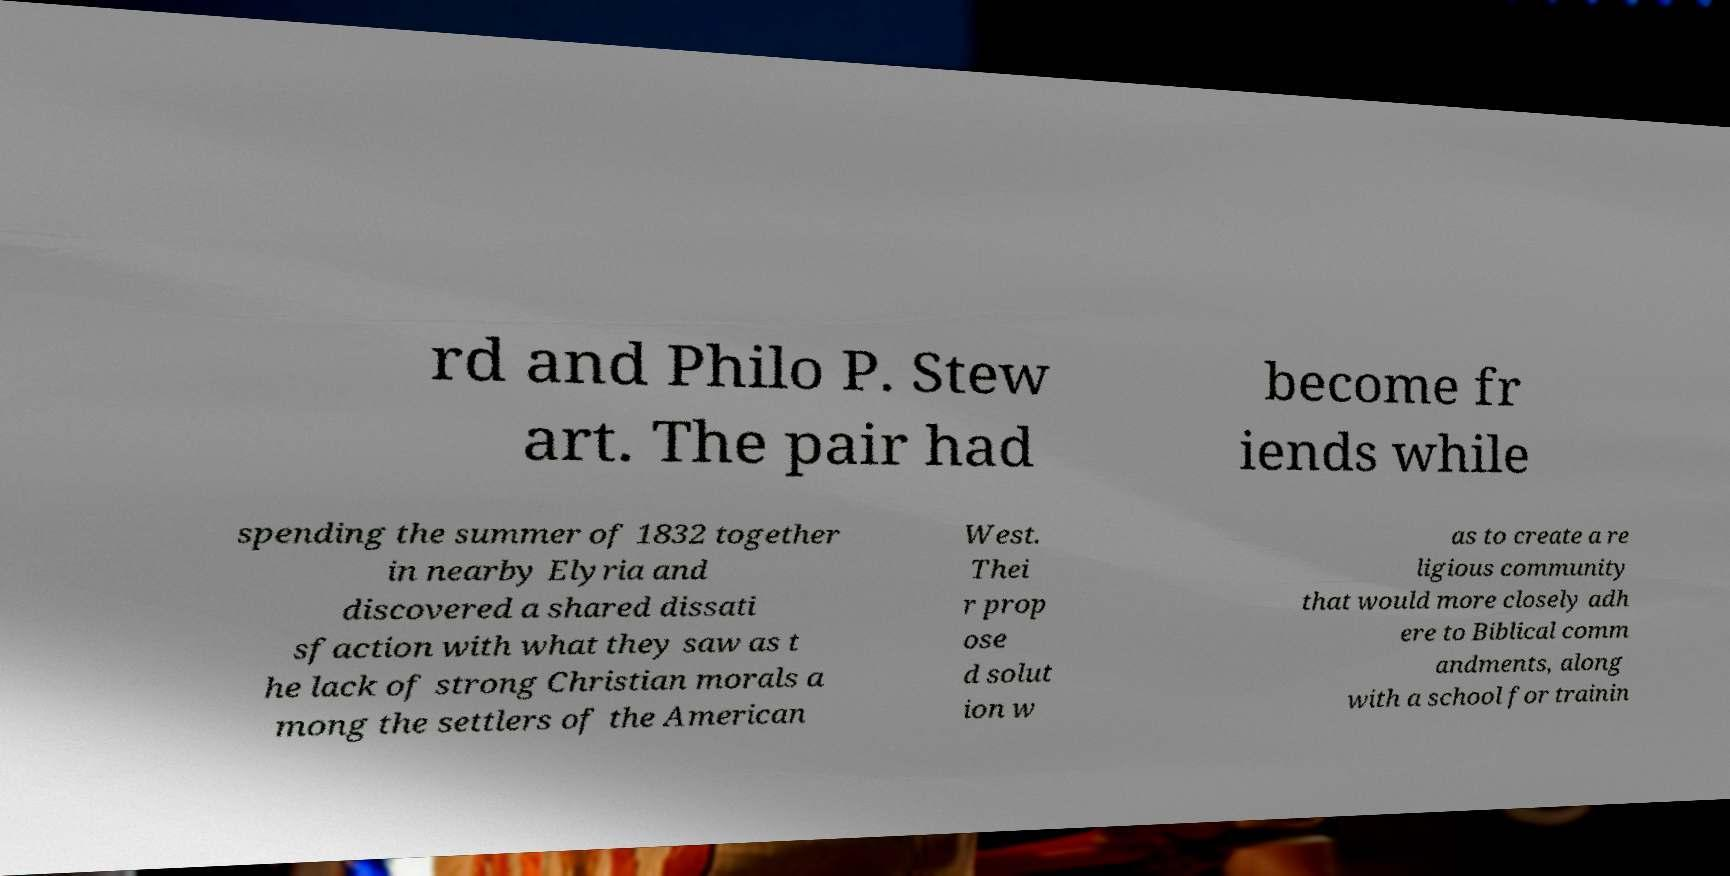What messages or text are displayed in this image? I need them in a readable, typed format. rd and Philo P. Stew art. The pair had become fr iends while spending the summer of 1832 together in nearby Elyria and discovered a shared dissati sfaction with what they saw as t he lack of strong Christian morals a mong the settlers of the American West. Thei r prop ose d solut ion w as to create a re ligious community that would more closely adh ere to Biblical comm andments, along with a school for trainin 